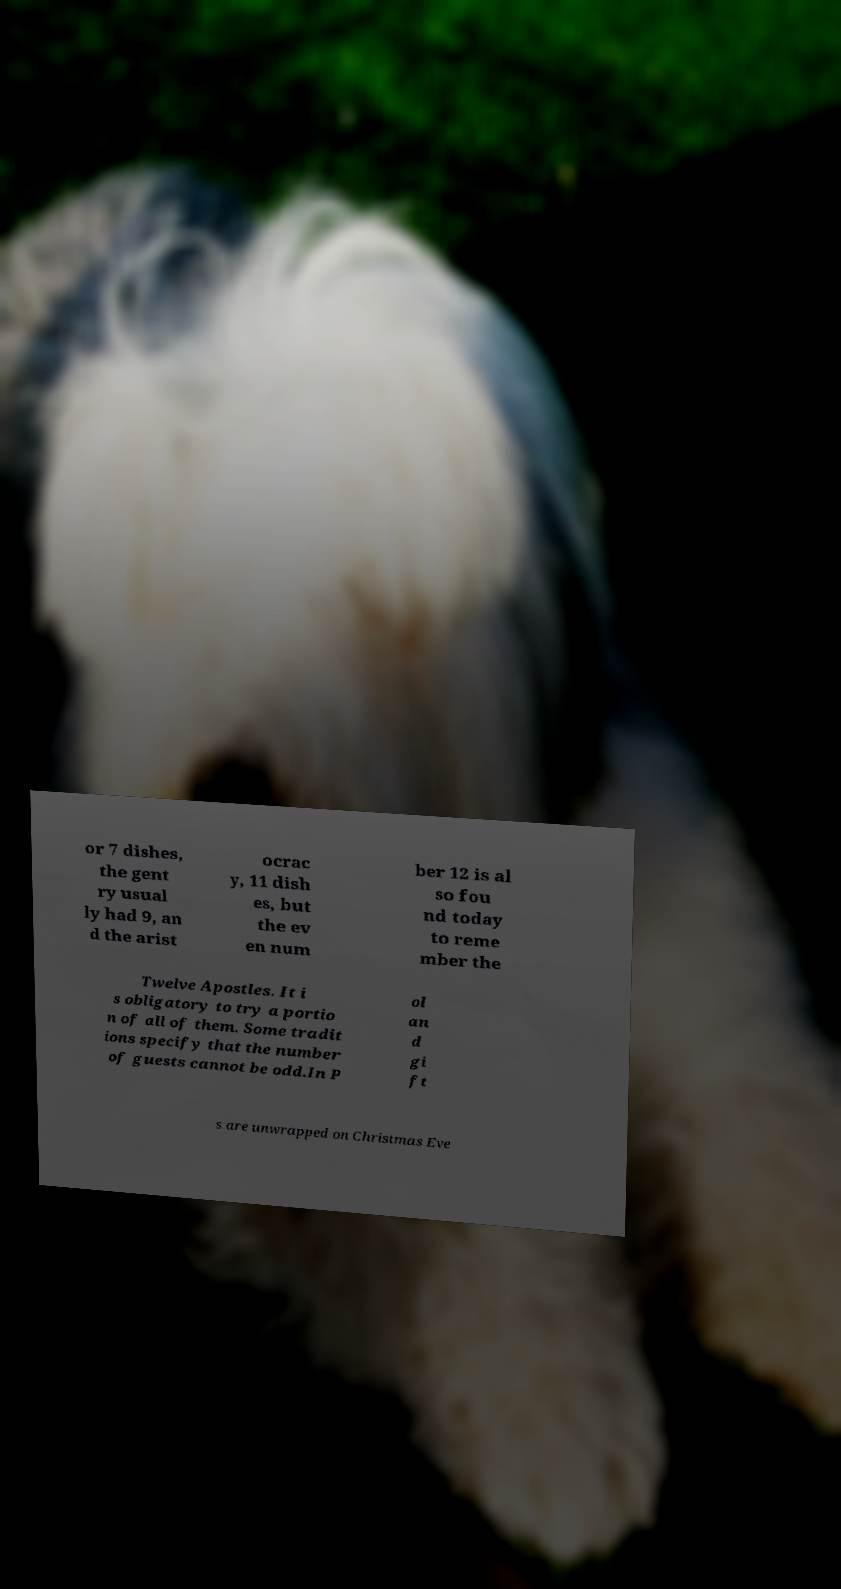Please identify and transcribe the text found in this image. or 7 dishes, the gent ry usual ly had 9, an d the arist ocrac y, 11 dish es, but the ev en num ber 12 is al so fou nd today to reme mber the Twelve Apostles. It i s obligatory to try a portio n of all of them. Some tradit ions specify that the number of guests cannot be odd.In P ol an d gi ft s are unwrapped on Christmas Eve 